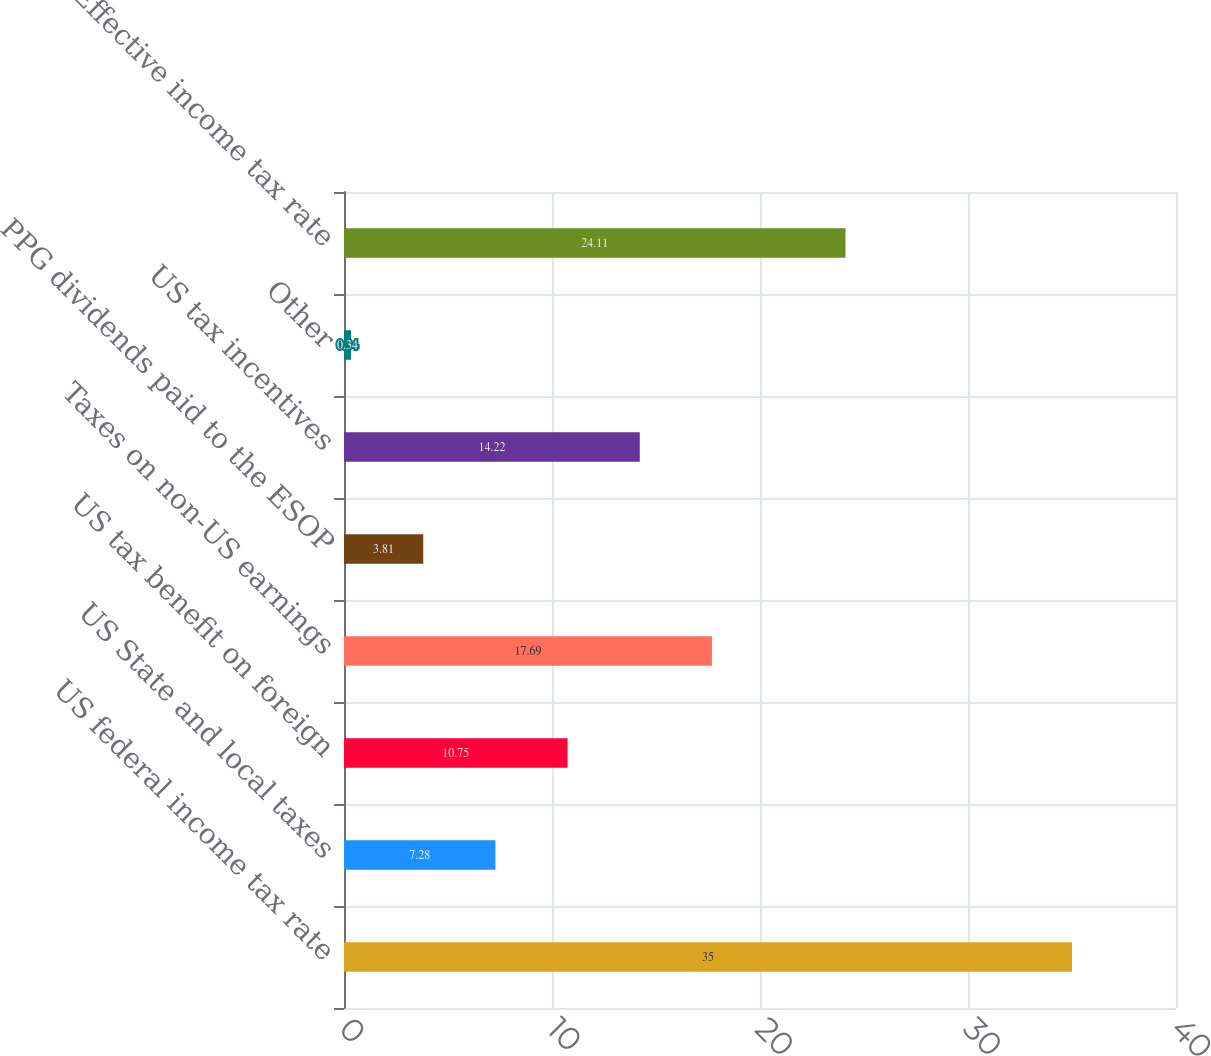Convert chart to OTSL. <chart><loc_0><loc_0><loc_500><loc_500><bar_chart><fcel>US federal income tax rate<fcel>US State and local taxes<fcel>US tax benefit on foreign<fcel>Taxes on non-US earnings<fcel>PPG dividends paid to the ESOP<fcel>US tax incentives<fcel>Other<fcel>Effective income tax rate<nl><fcel>35<fcel>7.28<fcel>10.75<fcel>17.69<fcel>3.81<fcel>14.22<fcel>0.34<fcel>24.11<nl></chart> 